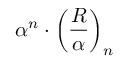<formula> <loc_0><loc_0><loc_500><loc_500>\alpha ^ { n } \cdot \left ( { \frac { R } { \alpha } } \right ) _ { n }</formula> 